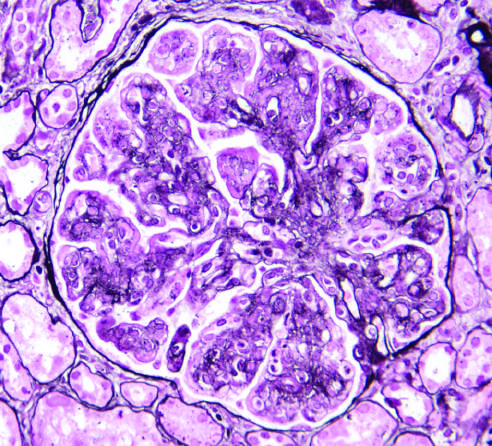did membranoproliferative glomerulonephritis (mpgn) show mesangial cell proliferation, basement membrane duplication, leukocyte infiltration, and accentuation of lobular architecture?
Answer the question using a single word or phrase. Yes 